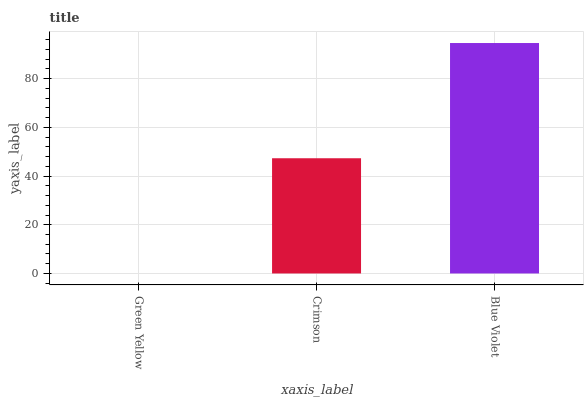Is Green Yellow the minimum?
Answer yes or no. Yes. Is Blue Violet the maximum?
Answer yes or no. Yes. Is Crimson the minimum?
Answer yes or no. No. Is Crimson the maximum?
Answer yes or no. No. Is Crimson greater than Green Yellow?
Answer yes or no. Yes. Is Green Yellow less than Crimson?
Answer yes or no. Yes. Is Green Yellow greater than Crimson?
Answer yes or no. No. Is Crimson less than Green Yellow?
Answer yes or no. No. Is Crimson the high median?
Answer yes or no. Yes. Is Crimson the low median?
Answer yes or no. Yes. Is Blue Violet the high median?
Answer yes or no. No. Is Green Yellow the low median?
Answer yes or no. No. 